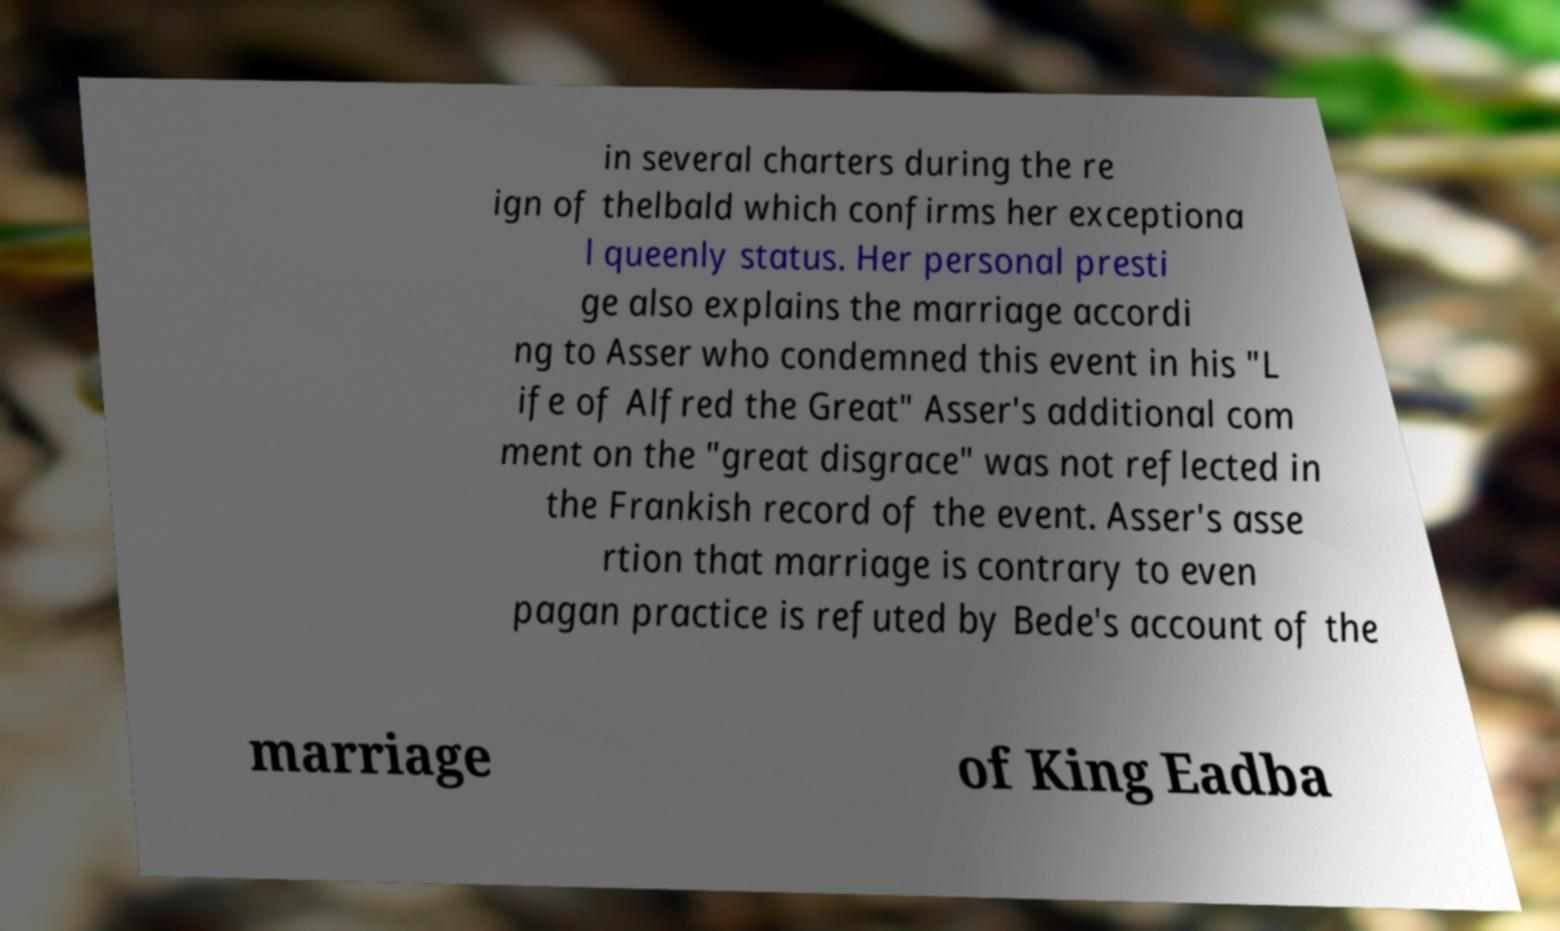Could you assist in decoding the text presented in this image and type it out clearly? in several charters during the re ign of thelbald which confirms her exceptiona l queenly status. Her personal presti ge also explains the marriage accordi ng to Asser who condemned this event in his "L ife of Alfred the Great" Asser's additional com ment on the "great disgrace" was not reflected in the Frankish record of the event. Asser's asse rtion that marriage is contrary to even pagan practice is refuted by Bede's account of the marriage of King Eadba 